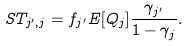<formula> <loc_0><loc_0><loc_500><loc_500>S T _ { j ^ { \prime } , j } = f _ { j ^ { \prime } } E [ Q _ { j } ] \frac { \gamma _ { j ^ { \prime } } } { 1 - \gamma _ { j } } .</formula> 